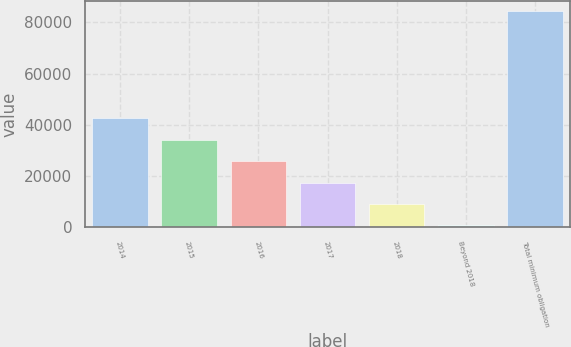<chart> <loc_0><loc_0><loc_500><loc_500><bar_chart><fcel>2014<fcel>2015<fcel>2016<fcel>2017<fcel>2018<fcel>Beyond 2018<fcel>Total minimum obligation<nl><fcel>42576<fcel>34222<fcel>25868<fcel>17514<fcel>9160<fcel>806<fcel>84346<nl></chart> 